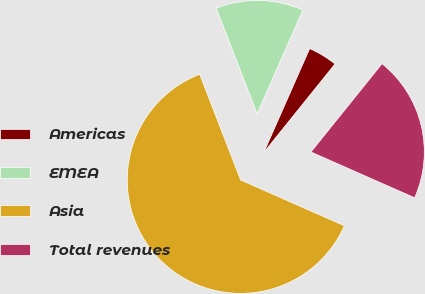Convert chart to OTSL. <chart><loc_0><loc_0><loc_500><loc_500><pie_chart><fcel>Americas<fcel>EMEA<fcel>Asia<fcel>Total revenues<nl><fcel>4.17%<fcel>12.5%<fcel>62.5%<fcel>20.83%<nl></chart> 